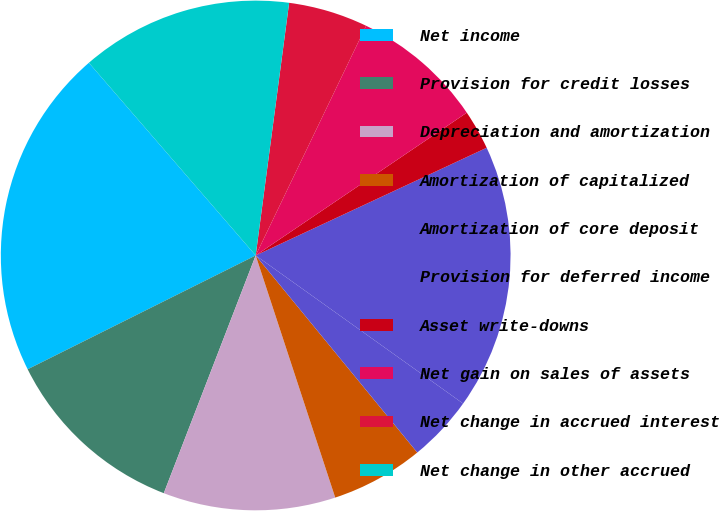Convert chart to OTSL. <chart><loc_0><loc_0><loc_500><loc_500><pie_chart><fcel>Net income<fcel>Provision for credit losses<fcel>Depreciation and amortization<fcel>Amortization of capitalized<fcel>Amortization of core deposit<fcel>Provision for deferred income<fcel>Asset write-downs<fcel>Net gain on sales of assets<fcel>Net change in accrued interest<fcel>Net change in other accrued<nl><fcel>21.01%<fcel>11.76%<fcel>10.92%<fcel>5.88%<fcel>4.2%<fcel>16.81%<fcel>2.52%<fcel>8.4%<fcel>5.04%<fcel>13.45%<nl></chart> 